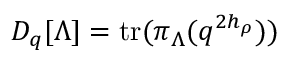Convert formula to latex. <formula><loc_0><loc_0><loc_500><loc_500>D _ { q } [ \Lambda ] = t r ( \pi _ { \Lambda } ( q ^ { 2 h _ { \rho } } ) )</formula> 